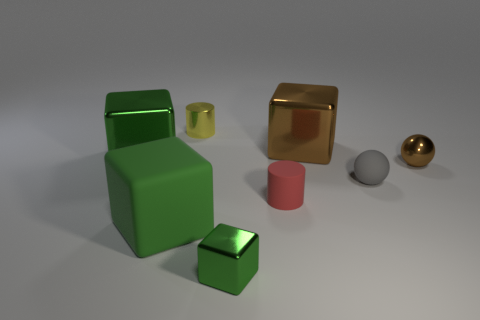Is the large matte thing the same color as the tiny metallic cube?
Provide a short and direct response. Yes. The matte thing that is both on the left side of the gray rubber sphere and on the right side of the yellow metallic cylinder is what color?
Provide a succinct answer. Red. Are there any big blocks on the left side of the large metallic thing that is behind the large metallic cube that is left of the rubber cylinder?
Give a very brief answer. Yes. How many objects are either gray matte spheres or shiny cubes?
Offer a terse response. 4. Is the large brown cube made of the same material as the small object behind the big brown object?
Offer a very short reply. Yes. Are there any other things that have the same color as the big matte thing?
Your answer should be very brief. Yes. What number of objects are either blocks in front of the big green shiny object or large brown metallic objects on the left side of the small brown object?
Offer a very short reply. 3. There is a tiny metal object that is both behind the gray ball and in front of the metal cylinder; what shape is it?
Keep it short and to the point. Sphere. There is a big thing that is behind the large green metal thing; how many yellow cylinders are right of it?
Give a very brief answer. 0. What number of objects are objects that are in front of the small gray matte object or green rubber blocks?
Provide a short and direct response. 3. 